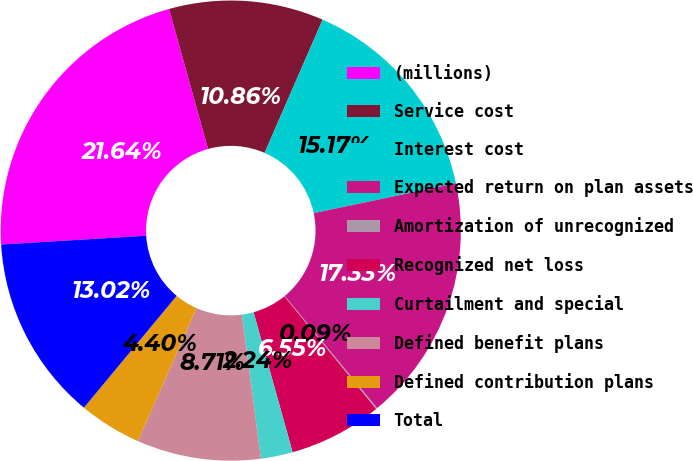Convert chart to OTSL. <chart><loc_0><loc_0><loc_500><loc_500><pie_chart><fcel>(millions)<fcel>Service cost<fcel>Interest cost<fcel>Expected return on plan assets<fcel>Amortization of unrecognized<fcel>Recognized net loss<fcel>Curtailment and special<fcel>Defined benefit plans<fcel>Defined contribution plans<fcel>Total<nl><fcel>21.64%<fcel>10.86%<fcel>15.17%<fcel>17.33%<fcel>0.09%<fcel>6.55%<fcel>2.24%<fcel>8.71%<fcel>4.4%<fcel>13.02%<nl></chart> 